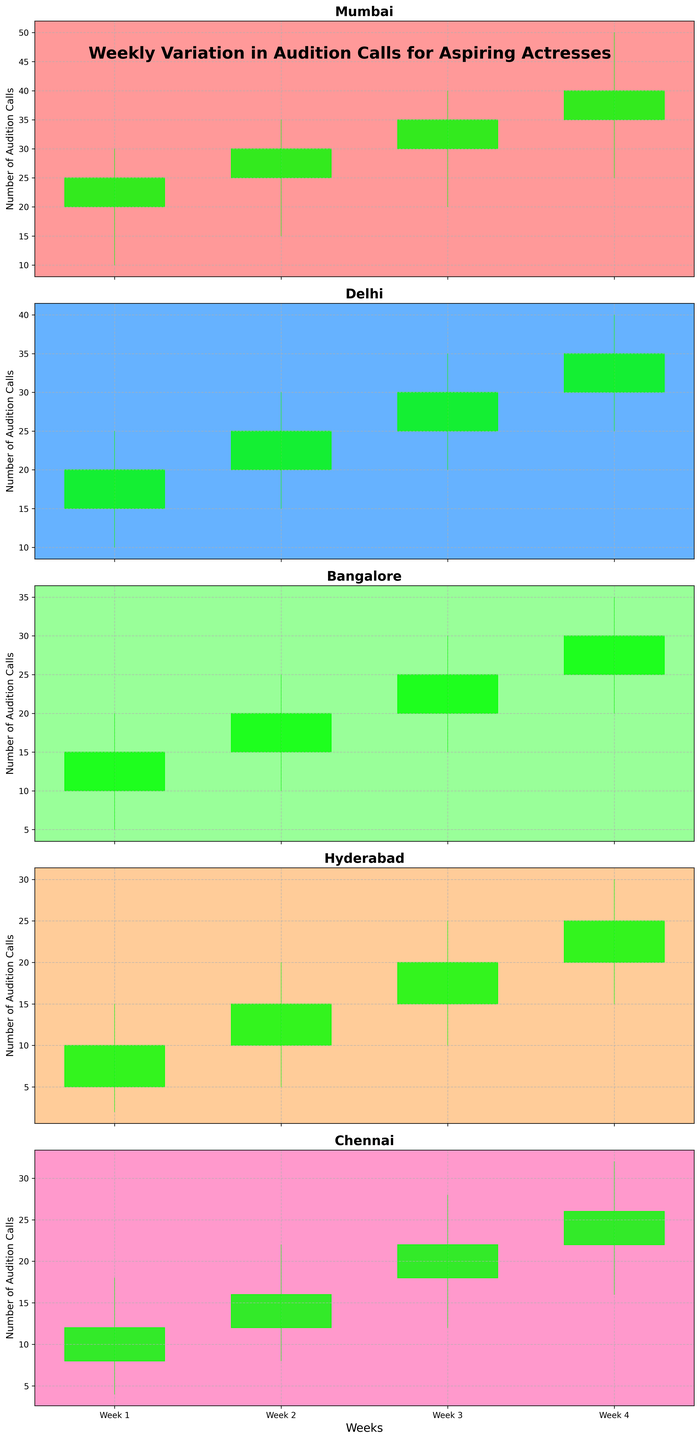Which city has the highest closing number of audition calls in week 4? Look at the closing values of each city in week 4, and identify the highest one. Mumbai has a closing value of 40, which is the highest among all cities.
Answer: Mumbai What is the trend of audition calls for Delhi over the weeks? Examine the candlestick for Delhi from week 1 to week 4. The closing values are increasing from 20 to 35, indicating a positive trend.
Answer: Increasing Which city starts with the lowest number of audition calls in week 1? Compare the 'Open' values of all cities in week 1. Hyderabad starts with 5, which is the lowest.
Answer: Hyderabad What is the range of audition calls in Bangalore during week 2? The range is determined by the difference between the 'High' and 'Low' values. For Bangalore in week 2, it is 25 - 10 = 15.
Answer: 15 How do the closing values of Mumbai and Bangalore compare in week 3? Look at the closing values of Mumbai (35) and Bangalore (25) in week 3. Mumbai's closing value is higher than Bangalore's by 10.
Answer: Mumbai's is higher by 10 In which weeks does Chennai have the highest increment in closing values? Look at the increment between consecutive weeks. The increments are: Week 1 to 2: 4, Week 2 to 3: 6, Week 3 to 4: 4. Week 2 to 3 has the highest increment of 6.
Answer: Week 2 to 3 What is the overall trend of audition calls in Hyderabad from week 1 to week 4? Examine the closing values from week 1 (10) to week 4 (25). They are steadily increasing over the weeks.
Answer: Increasing Which city has the most stable (least volatile) audition calls in week 1? Assess which city's range (High-Low) in week 1 is the smallest. Mumbai (20), Delhi (15), Bangalore (15), Hyderabad (13), and Chennai (14). Hyderabad has the smallest range of 13.
Answer: Hyderabad Compare the maximum audition calls (high values) for Mumbai and Chennai in week 4. Look at the 'High' values for Mumbai (50) and Chennai (32) in week 4. Mumbai's value is significantly higher than Chennai's by 18.
Answer: Mumbai's is higher by 18 